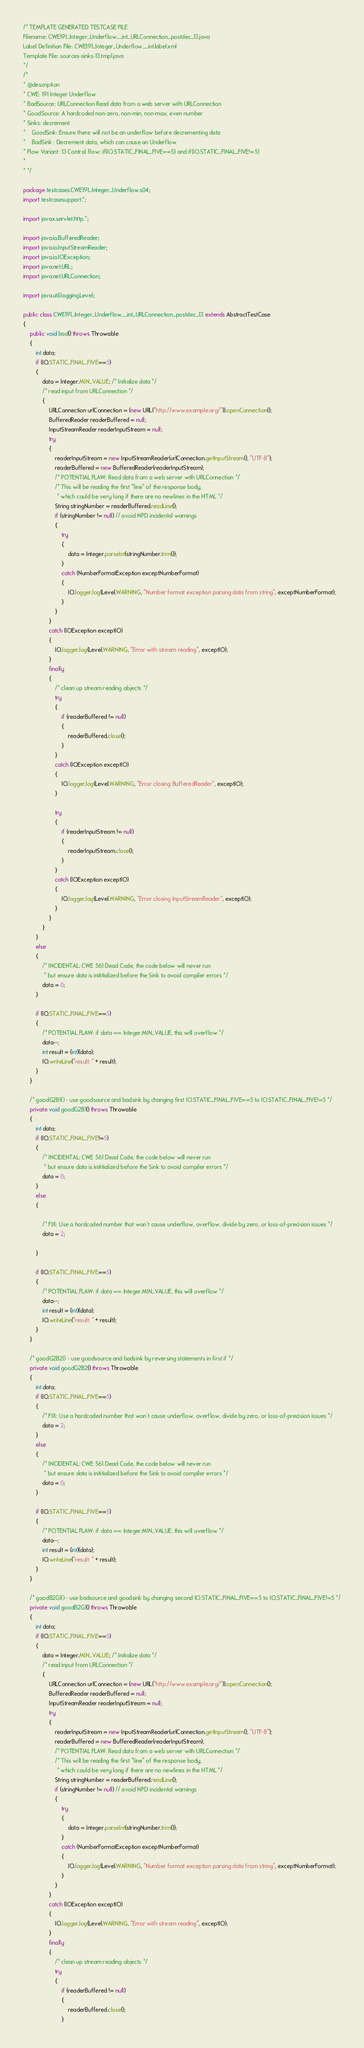Convert code to text. <code><loc_0><loc_0><loc_500><loc_500><_Java_>/* TEMPLATE GENERATED TESTCASE FILE
Filename: CWE191_Integer_Underflow__int_URLConnection_postdec_13.java
Label Definition File: CWE191_Integer_Underflow__int.label.xml
Template File: sources-sinks-13.tmpl.java
*/
/*
* @description
* CWE: 191 Integer Underflow
* BadSource: URLConnection Read data from a web server with URLConnection
* GoodSource: A hardcoded non-zero, non-min, non-max, even number
* Sinks: decrement
*    GoodSink: Ensure there will not be an underflow before decrementing data
*    BadSink : Decrement data, which can cause an Underflow
* Flow Variant: 13 Control flow: if(IO.STATIC_FINAL_FIVE==5) and if(IO.STATIC_FINAL_FIVE!=5)
*
* */

package testcases.CWE191_Integer_Underflow.s04;
import testcasesupport.*;

import javax.servlet.http.*;

import java.io.BufferedReader;
import java.io.InputStreamReader;
import java.io.IOException;
import java.net.URL;
import java.net.URLConnection;

import java.util.logging.Level;

public class CWE191_Integer_Underflow__int_URLConnection_postdec_13 extends AbstractTestCase
{
    public void bad() throws Throwable
    {
        int data;
        if (IO.STATIC_FINAL_FIVE==5)
        {
            data = Integer.MIN_VALUE; /* Initialize data */
            /* read input from URLConnection */
            {
                URLConnection urlConnection = (new URL("http://www.example.org/")).openConnection();
                BufferedReader readerBuffered = null;
                InputStreamReader readerInputStream = null;
                try
                {
                    readerInputStream = new InputStreamReader(urlConnection.getInputStream(), "UTF-8");
                    readerBuffered = new BufferedReader(readerInputStream);
                    /* POTENTIAL FLAW: Read data from a web server with URLConnection */
                    /* This will be reading the first "line" of the response body,
                     * which could be very long if there are no newlines in the HTML */
                    String stringNumber = readerBuffered.readLine();
                    if (stringNumber != null) // avoid NPD incidental warnings
                    {
                        try
                        {
                            data = Integer.parseInt(stringNumber.trim());
                        }
                        catch (NumberFormatException exceptNumberFormat)
                        {
                            IO.logger.log(Level.WARNING, "Number format exception parsing data from string", exceptNumberFormat);
                        }
                    }
                }
                catch (IOException exceptIO)
                {
                    IO.logger.log(Level.WARNING, "Error with stream reading", exceptIO);
                }
                finally
                {
                    /* clean up stream reading objects */
                    try
                    {
                        if (readerBuffered != null)
                        {
                            readerBuffered.close();
                        }
                    }
                    catch (IOException exceptIO)
                    {
                        IO.logger.log(Level.WARNING, "Error closing BufferedReader", exceptIO);
                    }

                    try
                    {
                        if (readerInputStream != null)
                        {
                            readerInputStream.close();
                        }
                    }
                    catch (IOException exceptIO)
                    {
                        IO.logger.log(Level.WARNING, "Error closing InputStreamReader", exceptIO);
                    }
                }
            }
        }
        else
        {
            /* INCIDENTAL: CWE 561 Dead Code, the code below will never run
             * but ensure data is inititialized before the Sink to avoid compiler errors */
            data = 0;
        }

        if (IO.STATIC_FINAL_FIVE==5)
        {
            /* POTENTIAL FLAW: if data == Integer.MIN_VALUE, this will overflow */
            data--;
            int result = (int)(data);
            IO.writeLine("result: " + result);
        }
    }

    /* goodG2B1() - use goodsource and badsink by changing first IO.STATIC_FINAL_FIVE==5 to IO.STATIC_FINAL_FIVE!=5 */
    private void goodG2B1() throws Throwable
    {
        int data;
        if (IO.STATIC_FINAL_FIVE!=5)
        {
            /* INCIDENTAL: CWE 561 Dead Code, the code below will never run
             * but ensure data is inititialized before the Sink to avoid compiler errors */
            data = 0;
        }
        else
        {

            /* FIX: Use a hardcoded number that won't cause underflow, overflow, divide by zero, or loss-of-precision issues */
            data = 2;

        }

        if (IO.STATIC_FINAL_FIVE==5)
        {
            /* POTENTIAL FLAW: if data == Integer.MIN_VALUE, this will overflow */
            data--;
            int result = (int)(data);
            IO.writeLine("result: " + result);
        }
    }

    /* goodG2B2() - use goodsource and badsink by reversing statements in first if */
    private void goodG2B2() throws Throwable
    {
        int data;
        if (IO.STATIC_FINAL_FIVE==5)
        {
            /* FIX: Use a hardcoded number that won't cause underflow, overflow, divide by zero, or loss-of-precision issues */
            data = 2;
        }
        else
        {
            /* INCIDENTAL: CWE 561 Dead Code, the code below will never run
             * but ensure data is inititialized before the Sink to avoid compiler errors */
            data = 0;
        }

        if (IO.STATIC_FINAL_FIVE==5)
        {
            /* POTENTIAL FLAW: if data == Integer.MIN_VALUE, this will overflow */
            data--;
            int result = (int)(data);
            IO.writeLine("result: " + result);
        }
    }

    /* goodB2G1() - use badsource and goodsink by changing second IO.STATIC_FINAL_FIVE==5 to IO.STATIC_FINAL_FIVE!=5 */
    private void goodB2G1() throws Throwable
    {
        int data;
        if (IO.STATIC_FINAL_FIVE==5)
        {
            data = Integer.MIN_VALUE; /* Initialize data */
            /* read input from URLConnection */
            {
                URLConnection urlConnection = (new URL("http://www.example.org/")).openConnection();
                BufferedReader readerBuffered = null;
                InputStreamReader readerInputStream = null;
                try
                {
                    readerInputStream = new InputStreamReader(urlConnection.getInputStream(), "UTF-8");
                    readerBuffered = new BufferedReader(readerInputStream);
                    /* POTENTIAL FLAW: Read data from a web server with URLConnection */
                    /* This will be reading the first "line" of the response body,
                     * which could be very long if there are no newlines in the HTML */
                    String stringNumber = readerBuffered.readLine();
                    if (stringNumber != null) // avoid NPD incidental warnings
                    {
                        try
                        {
                            data = Integer.parseInt(stringNumber.trim());
                        }
                        catch (NumberFormatException exceptNumberFormat)
                        {
                            IO.logger.log(Level.WARNING, "Number format exception parsing data from string", exceptNumberFormat);
                        }
                    }
                }
                catch (IOException exceptIO)
                {
                    IO.logger.log(Level.WARNING, "Error with stream reading", exceptIO);
                }
                finally
                {
                    /* clean up stream reading objects */
                    try
                    {
                        if (readerBuffered != null)
                        {
                            readerBuffered.close();
                        }</code> 